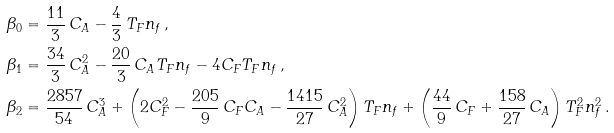<formula> <loc_0><loc_0><loc_500><loc_500>\beta _ { 0 } & = \frac { 1 1 } { 3 } \, C _ { A } - \frac { 4 } { 3 } \, T _ { F } n _ { f } \, , \\ \beta _ { 1 } & = \frac { 3 4 } { 3 } \, C _ { A } ^ { 2 } - \frac { 2 0 } { 3 } \, C _ { A } T _ { F } n _ { f } - 4 C _ { F } T _ { F } n _ { f } \, , \\ \beta _ { 2 } & = \frac { 2 8 5 7 } { 5 4 } \, C _ { A } ^ { 3 } + \left ( 2 C _ { F } ^ { 2 } - \frac { 2 0 5 } { 9 } \, C _ { F } C _ { A } - \frac { 1 4 1 5 } { 2 7 } \, C _ { A } ^ { 2 } \right ) T _ { F } n _ { f } + \left ( \frac { 4 4 } { 9 } \, C _ { F } + \frac { 1 5 8 } { 2 7 } \, C _ { A } \right ) T _ { F } ^ { 2 } n _ { f } ^ { 2 } \, .</formula> 